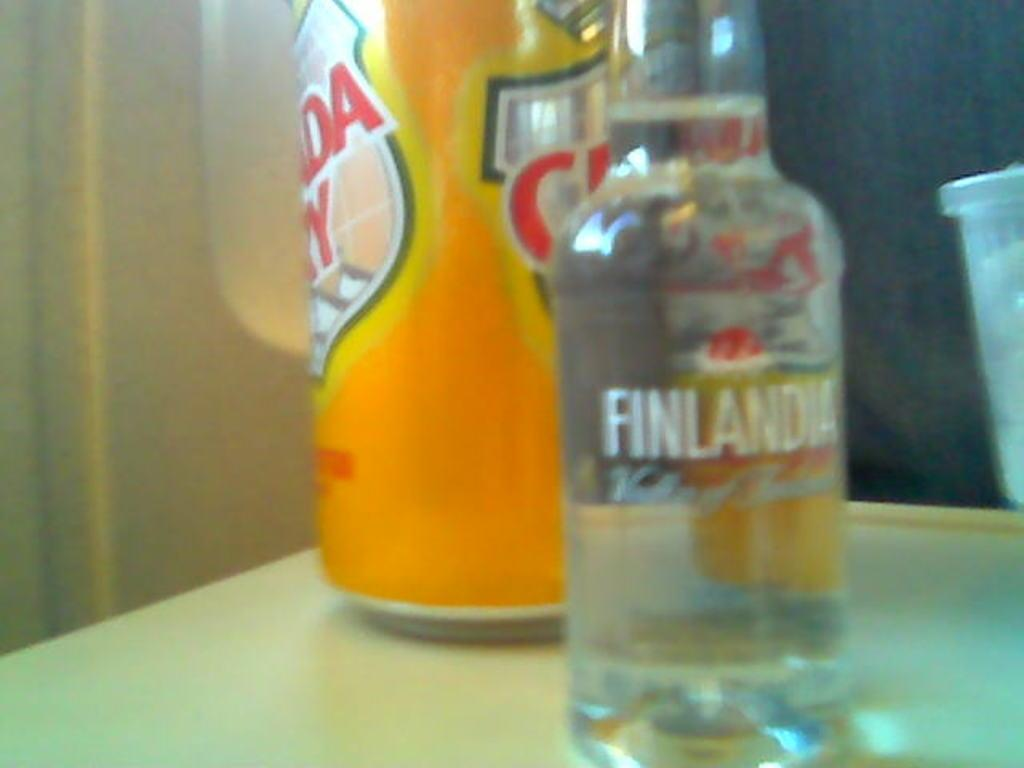Provide a one-sentence caption for the provided image. A bottle of Finlandia sits on a table next to a can of Canada Dry. 